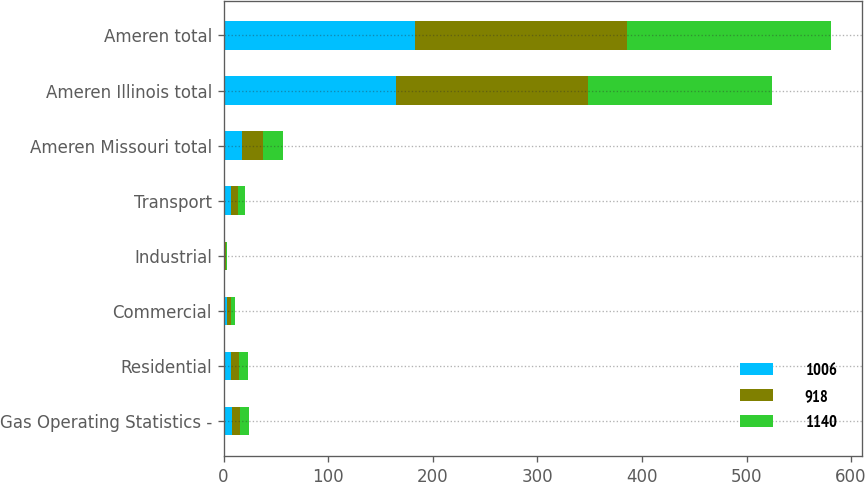<chart> <loc_0><loc_0><loc_500><loc_500><stacked_bar_chart><ecel><fcel>Gas Operating Statistics -<fcel>Residential<fcel>Commercial<fcel>Industrial<fcel>Transport<fcel>Ameren Missouri total<fcel>Ameren Illinois total<fcel>Ameren total<nl><fcel>1006<fcel>8<fcel>7<fcel>3<fcel>1<fcel>7<fcel>18<fcel>165<fcel>183<nl><fcel>918<fcel>8<fcel>8<fcel>4<fcel>1<fcel>7<fcel>20<fcel>183<fcel>203<nl><fcel>1140<fcel>8<fcel>8<fcel>4<fcel>1<fcel>6<fcel>19<fcel>176<fcel>195<nl></chart> 